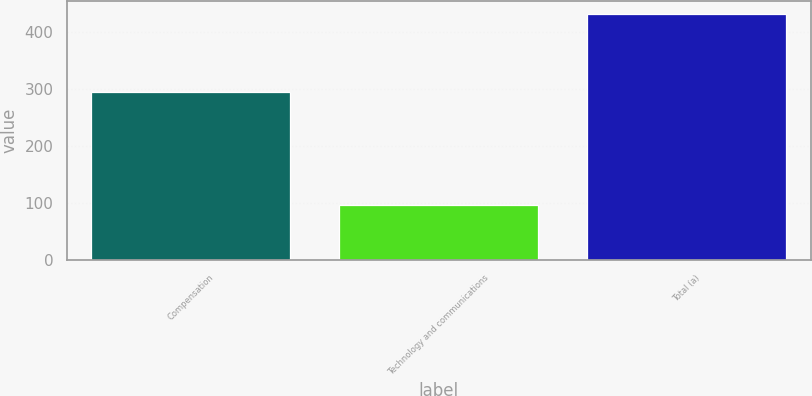Convert chart to OTSL. <chart><loc_0><loc_0><loc_500><loc_500><bar_chart><fcel>Compensation<fcel>Technology and communications<fcel>Total (a)<nl><fcel>294<fcel>96<fcel>432<nl></chart> 